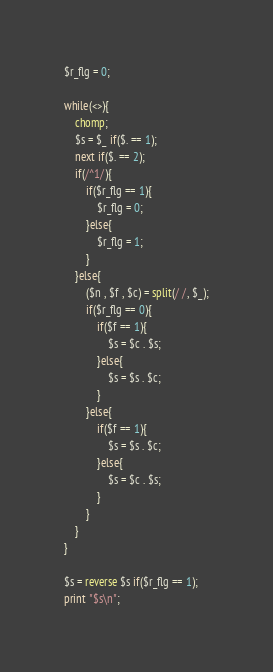Convert code to text. <code><loc_0><loc_0><loc_500><loc_500><_Perl_>$r_flg = 0;

while(<>){
	chomp;
	$s = $_ if($. == 1);
	next if($. == 2);
	if(/^1/){
		if($r_flg == 1){
			$r_flg = 0;
		}else{
			$r_flg = 1;
		}
	}else{
		($n , $f , $c) = split(/ /, $_);
		if($r_flg == 0){
			if($f == 1){
				$s = $c . $s;
			}else{
				$s = $s . $c;
			}
		}else{
			if($f == 1){
				$s = $s . $c;
			}else{
				$s = $c . $s;
			}
		}
	}
}

$s = reverse $s if($r_flg == 1);
print "$s\n";
</code> 